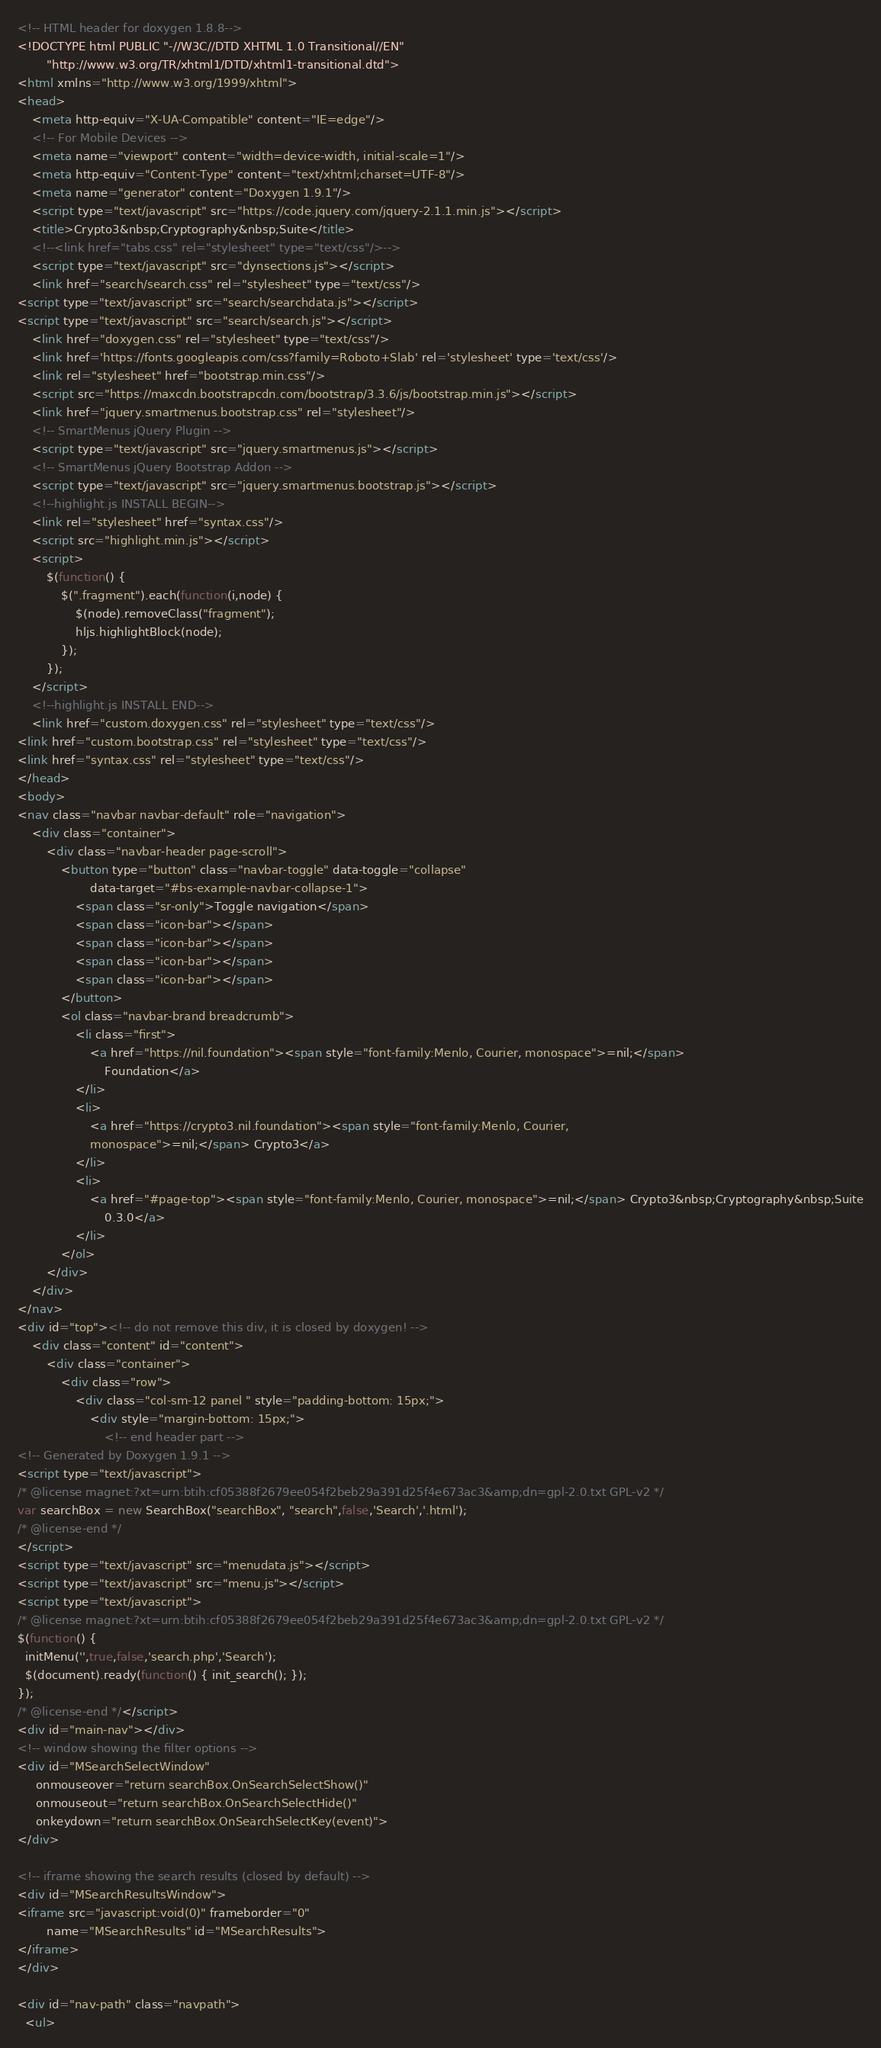Convert code to text. <code><loc_0><loc_0><loc_500><loc_500><_HTML_><!-- HTML header for doxygen 1.8.8-->
<!DOCTYPE html PUBLIC "-//W3C//DTD XHTML 1.0 Transitional//EN"
        "http://www.w3.org/TR/xhtml1/DTD/xhtml1-transitional.dtd">
<html xmlns="http://www.w3.org/1999/xhtml">
<head>
    <meta http-equiv="X-UA-Compatible" content="IE=edge"/>
    <!-- For Mobile Devices -->
    <meta name="viewport" content="width=device-width, initial-scale=1"/>
    <meta http-equiv="Content-Type" content="text/xhtml;charset=UTF-8"/>
    <meta name="generator" content="Doxygen 1.9.1"/>
    <script type="text/javascript" src="https://code.jquery.com/jquery-2.1.1.min.js"></script>
    <title>Crypto3&nbsp;Cryptography&nbsp;Suite</title>
    <!--<link href="tabs.css" rel="stylesheet" type="text/css"/>-->
    <script type="text/javascript" src="dynsections.js"></script>
    <link href="search/search.css" rel="stylesheet" type="text/css"/>
<script type="text/javascript" src="search/searchdata.js"></script>
<script type="text/javascript" src="search/search.js"></script>
    <link href="doxygen.css" rel="stylesheet" type="text/css"/>
    <link href='https://fonts.googleapis.com/css?family=Roboto+Slab' rel='stylesheet' type='text/css'/>
    <link rel="stylesheet" href="bootstrap.min.css"/>
    <script src="https://maxcdn.bootstrapcdn.com/bootstrap/3.3.6/js/bootstrap.min.js"></script>
    <link href="jquery.smartmenus.bootstrap.css" rel="stylesheet"/>
    <!-- SmartMenus jQuery Plugin -->
    <script type="text/javascript" src="jquery.smartmenus.js"></script>
    <!-- SmartMenus jQuery Bootstrap Addon -->
    <script type="text/javascript" src="jquery.smartmenus.bootstrap.js"></script>
    <!--highlight.js INSTALL BEGIN-->
    <link rel="stylesheet" href="syntax.css"/>
    <script src="highlight.min.js"></script>
    <script>
        $(function() {
            $(".fragment").each(function(i,node) {
                $(node).removeClass("fragment");
                hljs.highlightBlock(node);
            });
        });
    </script>
    <!--highlight.js INSTALL END-->
    <link href="custom.doxygen.css" rel="stylesheet" type="text/css"/>
<link href="custom.bootstrap.css" rel="stylesheet" type="text/css"/>
<link href="syntax.css" rel="stylesheet" type="text/css"/>
</head>
<body>
<nav class="navbar navbar-default" role="navigation">
    <div class="container">
        <div class="navbar-header page-scroll">
            <button type="button" class="navbar-toggle" data-toggle="collapse"
                    data-target="#bs-example-navbar-collapse-1">
                <span class="sr-only">Toggle navigation</span>
                <span class="icon-bar"></span>
                <span class="icon-bar"></span>
                <span class="icon-bar"></span>
                <span class="icon-bar"></span>
            </button>
            <ol class="navbar-brand breadcrumb">
                <li class="first">
                    <a href="https://nil.foundation"><span style="font-family:Menlo, Courier, monospace">=nil;</span>
                        Foundation</a>
                </li>
                <li>
                    <a href="https://crypto3.nil.foundation"><span style="font-family:Menlo, Courier,
                    monospace">=nil;</span> Crypto3</a>
                </li>
                <li>
                    <a href="#page-top"><span style="font-family:Menlo, Courier, monospace">=nil;</span> Crypto3&nbsp;Cryptography&nbsp;Suite
                        0.3.0</a>
                </li>
            </ol>
        </div>
    </div>
</nav>
<div id="top"><!-- do not remove this div, it is closed by doxygen! -->
    <div class="content" id="content">
        <div class="container">
            <div class="row">
                <div class="col-sm-12 panel " style="padding-bottom: 15px;">
                    <div style="margin-bottom: 15px;">
                        <!-- end header part -->
<!-- Generated by Doxygen 1.9.1 -->
<script type="text/javascript">
/* @license magnet:?xt=urn:btih:cf05388f2679ee054f2beb29a391d25f4e673ac3&amp;dn=gpl-2.0.txt GPL-v2 */
var searchBox = new SearchBox("searchBox", "search",false,'Search','.html');
/* @license-end */
</script>
<script type="text/javascript" src="menudata.js"></script>
<script type="text/javascript" src="menu.js"></script>
<script type="text/javascript">
/* @license magnet:?xt=urn:btih:cf05388f2679ee054f2beb29a391d25f4e673ac3&amp;dn=gpl-2.0.txt GPL-v2 */
$(function() {
  initMenu('',true,false,'search.php','Search');
  $(document).ready(function() { init_search(); });
});
/* @license-end */</script>
<div id="main-nav"></div>
<!-- window showing the filter options -->
<div id="MSearchSelectWindow"
     onmouseover="return searchBox.OnSearchSelectShow()"
     onmouseout="return searchBox.OnSearchSelectHide()"
     onkeydown="return searchBox.OnSearchSelectKey(event)">
</div>

<!-- iframe showing the search results (closed by default) -->
<div id="MSearchResultsWindow">
<iframe src="javascript:void(0)" frameborder="0" 
        name="MSearchResults" id="MSearchResults">
</iframe>
</div>

<div id="nav-path" class="navpath">
  <ul></code> 